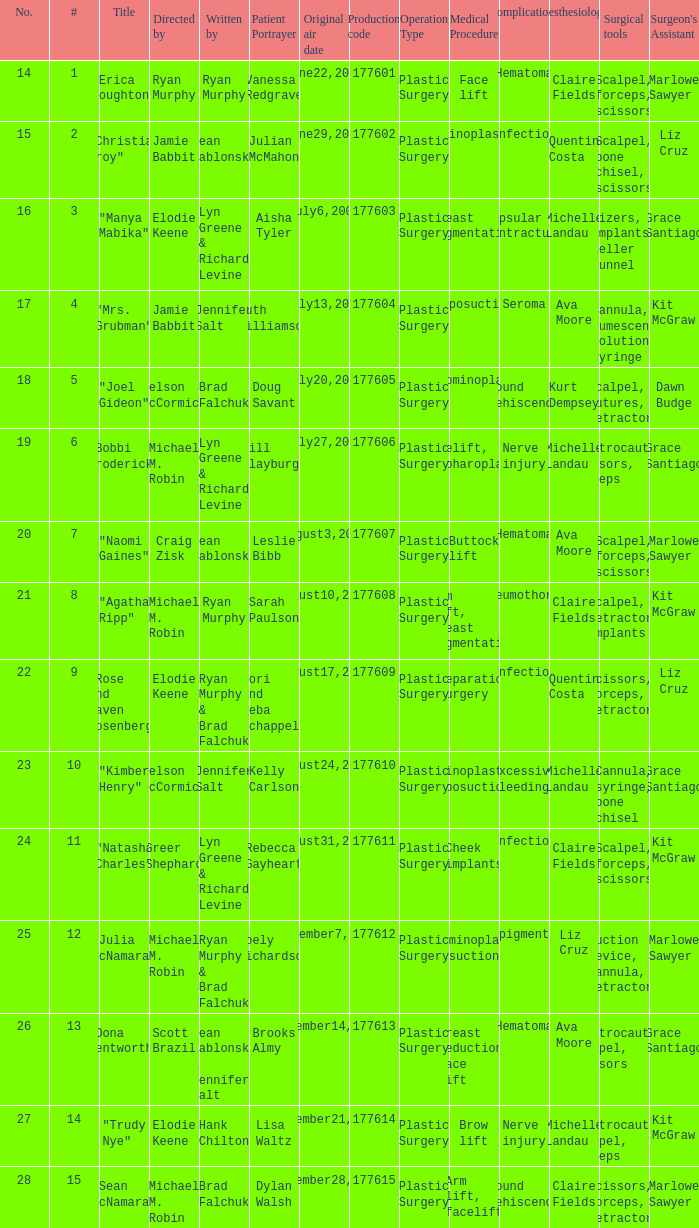Who directed the episode with production code 177605? Nelson McCormick. 